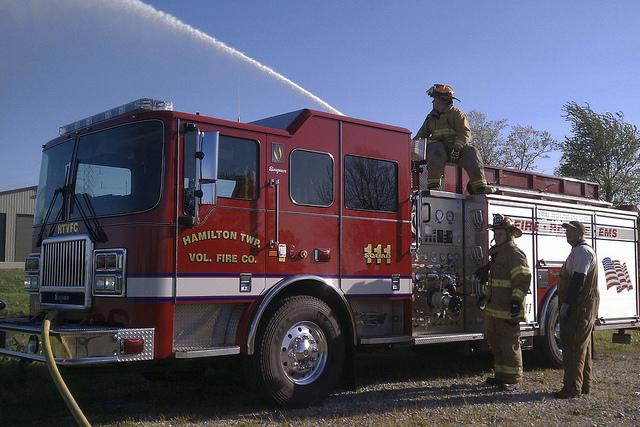What province does this fire crew reside in?

Choices:
A) alberta
B) nwt
C) ontario
D) pei ontario 